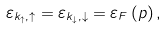Convert formula to latex. <formula><loc_0><loc_0><loc_500><loc_500>\varepsilon _ { k _ { \uparrow } , \uparrow } = \varepsilon _ { k _ { \downarrow } , \downarrow } = \varepsilon _ { F } \left ( p \right ) ,</formula> 